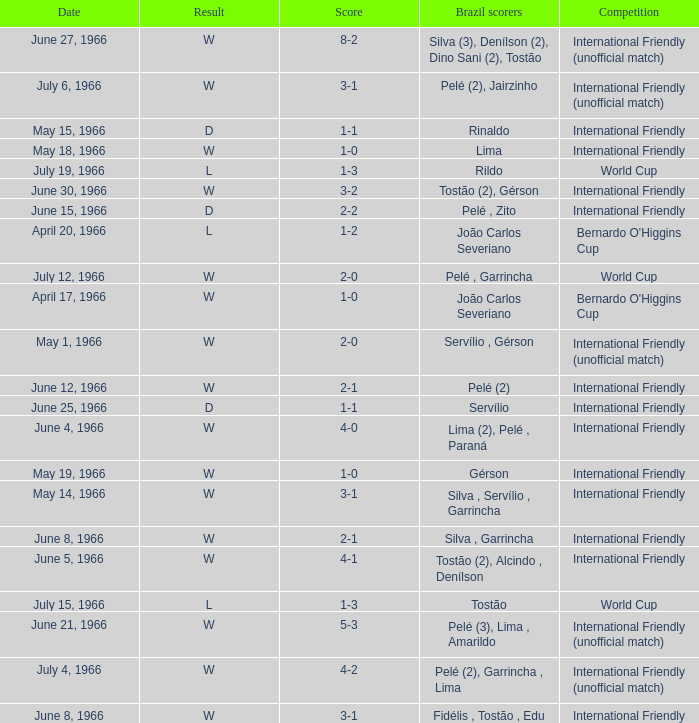What is the result of the International Friendly competition on May 15, 1966? D. 